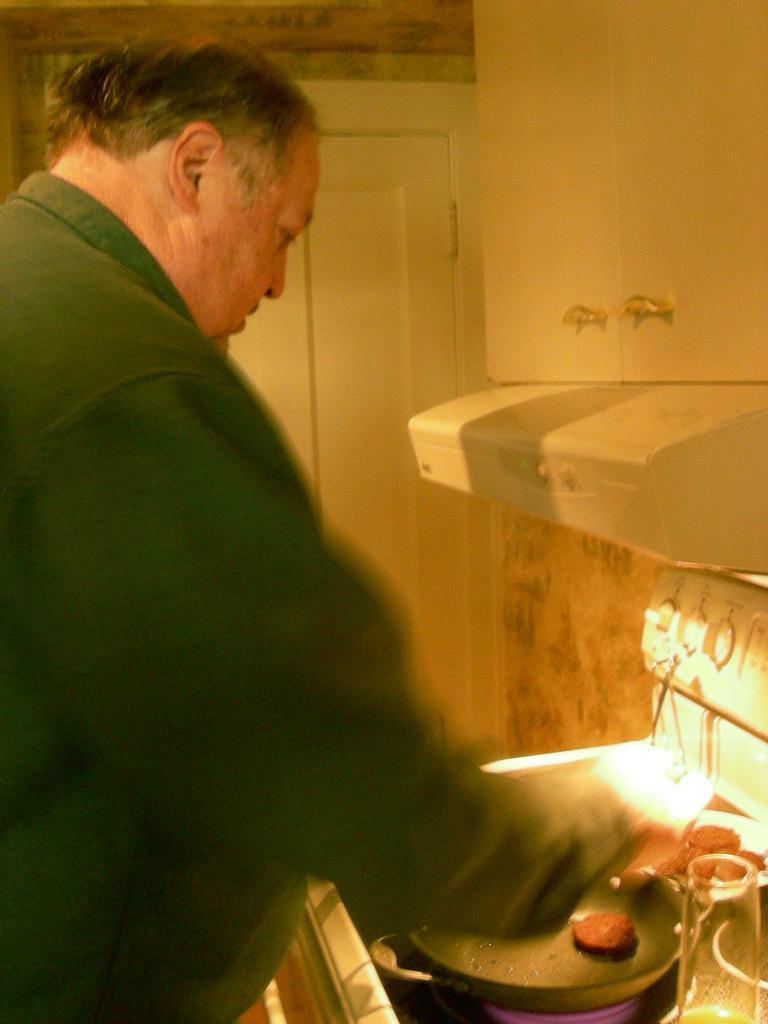Could you give a brief overview of what you see in this image? In this image in the center there is a man standing. On the right side there is a glass and there is a pan, on the pan there is a cookie and there is wardrobe on the wall. In the center there is a door which is white in colour and on the right side there are switches. 